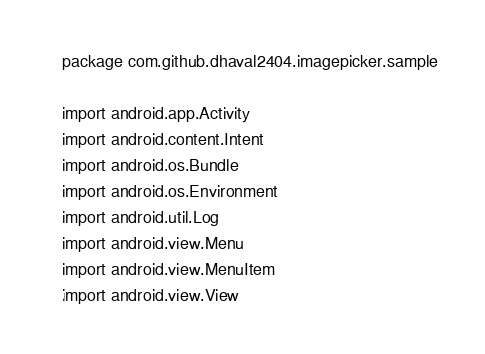<code> <loc_0><loc_0><loc_500><loc_500><_Kotlin_>package com.github.dhaval2404.imagepicker.sample

import android.app.Activity
import android.content.Intent
import android.os.Bundle
import android.os.Environment
import android.util.Log
import android.view.Menu
import android.view.MenuItem
import android.view.View</code> 